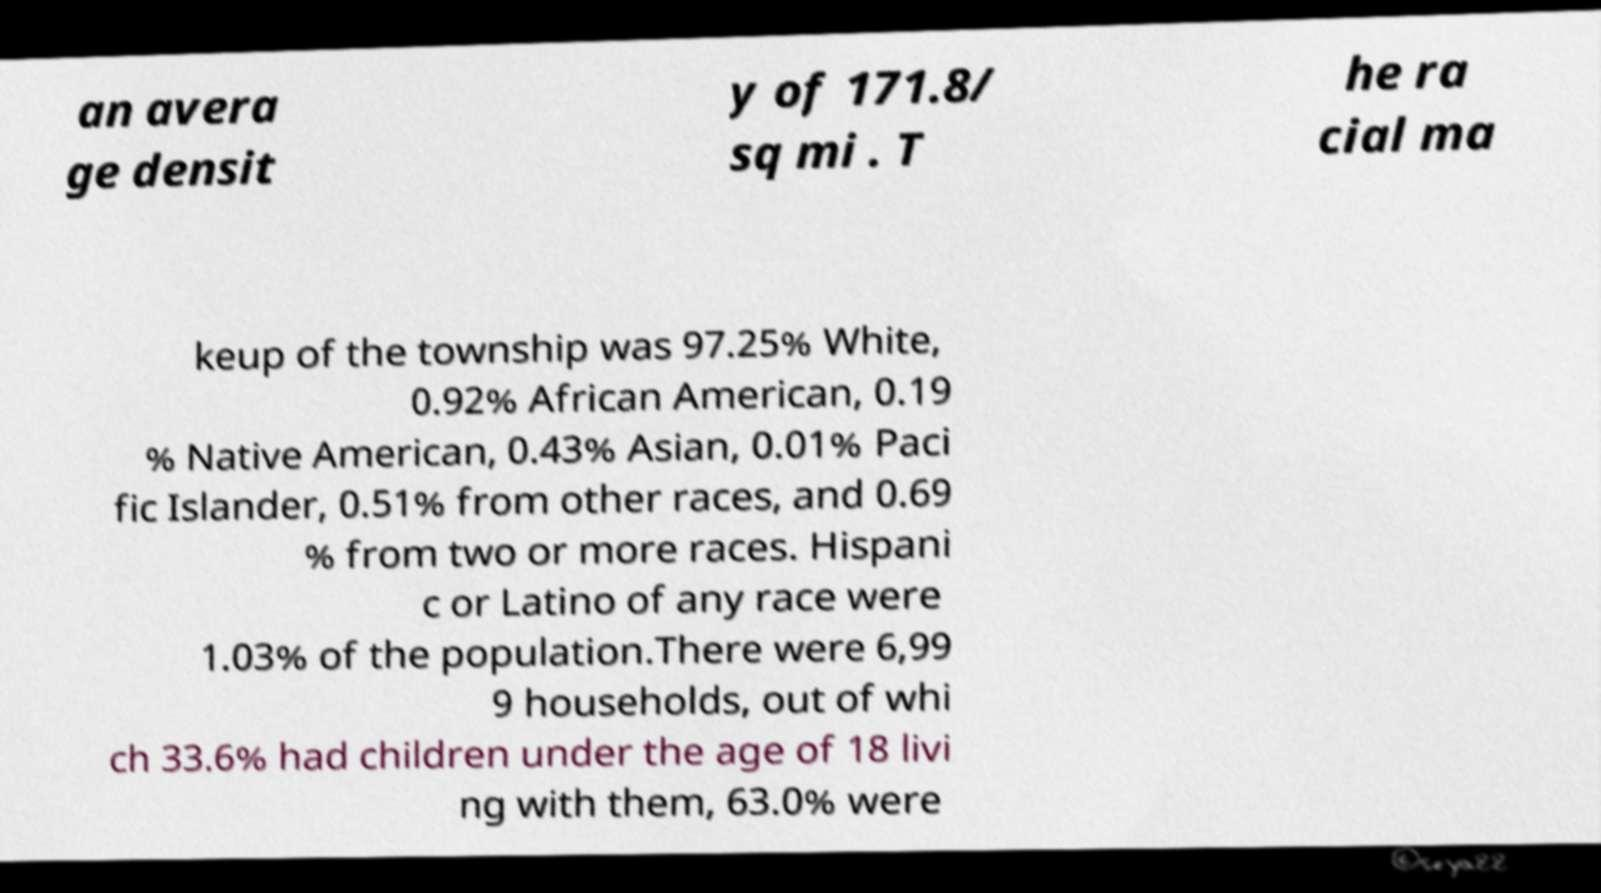Please identify and transcribe the text found in this image. an avera ge densit y of 171.8/ sq mi . T he ra cial ma keup of the township was 97.25% White, 0.92% African American, 0.19 % Native American, 0.43% Asian, 0.01% Paci fic Islander, 0.51% from other races, and 0.69 % from two or more races. Hispani c or Latino of any race were 1.03% of the population.There were 6,99 9 households, out of whi ch 33.6% had children under the age of 18 livi ng with them, 63.0% were 